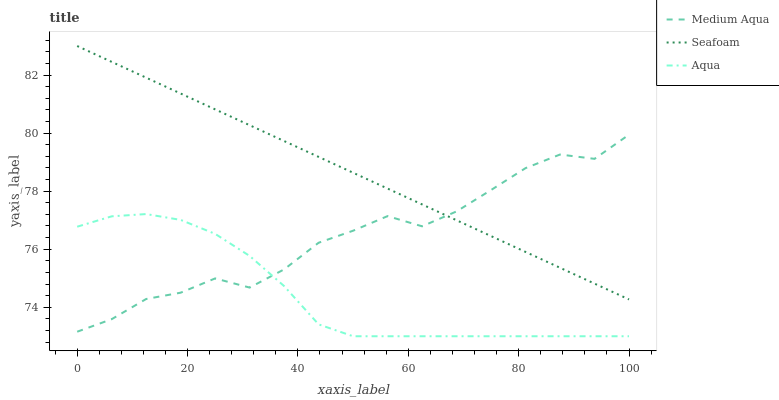Does Aqua have the minimum area under the curve?
Answer yes or no. Yes. Does Seafoam have the maximum area under the curve?
Answer yes or no. Yes. Does Medium Aqua have the minimum area under the curve?
Answer yes or no. No. Does Medium Aqua have the maximum area under the curve?
Answer yes or no. No. Is Seafoam the smoothest?
Answer yes or no. Yes. Is Medium Aqua the roughest?
Answer yes or no. Yes. Is Medium Aqua the smoothest?
Answer yes or no. No. Is Seafoam the roughest?
Answer yes or no. No. Does Aqua have the lowest value?
Answer yes or no. Yes. Does Medium Aqua have the lowest value?
Answer yes or no. No. Does Seafoam have the highest value?
Answer yes or no. Yes. Does Medium Aqua have the highest value?
Answer yes or no. No. Is Aqua less than Seafoam?
Answer yes or no. Yes. Is Seafoam greater than Aqua?
Answer yes or no. Yes. Does Aqua intersect Medium Aqua?
Answer yes or no. Yes. Is Aqua less than Medium Aqua?
Answer yes or no. No. Is Aqua greater than Medium Aqua?
Answer yes or no. No. Does Aqua intersect Seafoam?
Answer yes or no. No. 